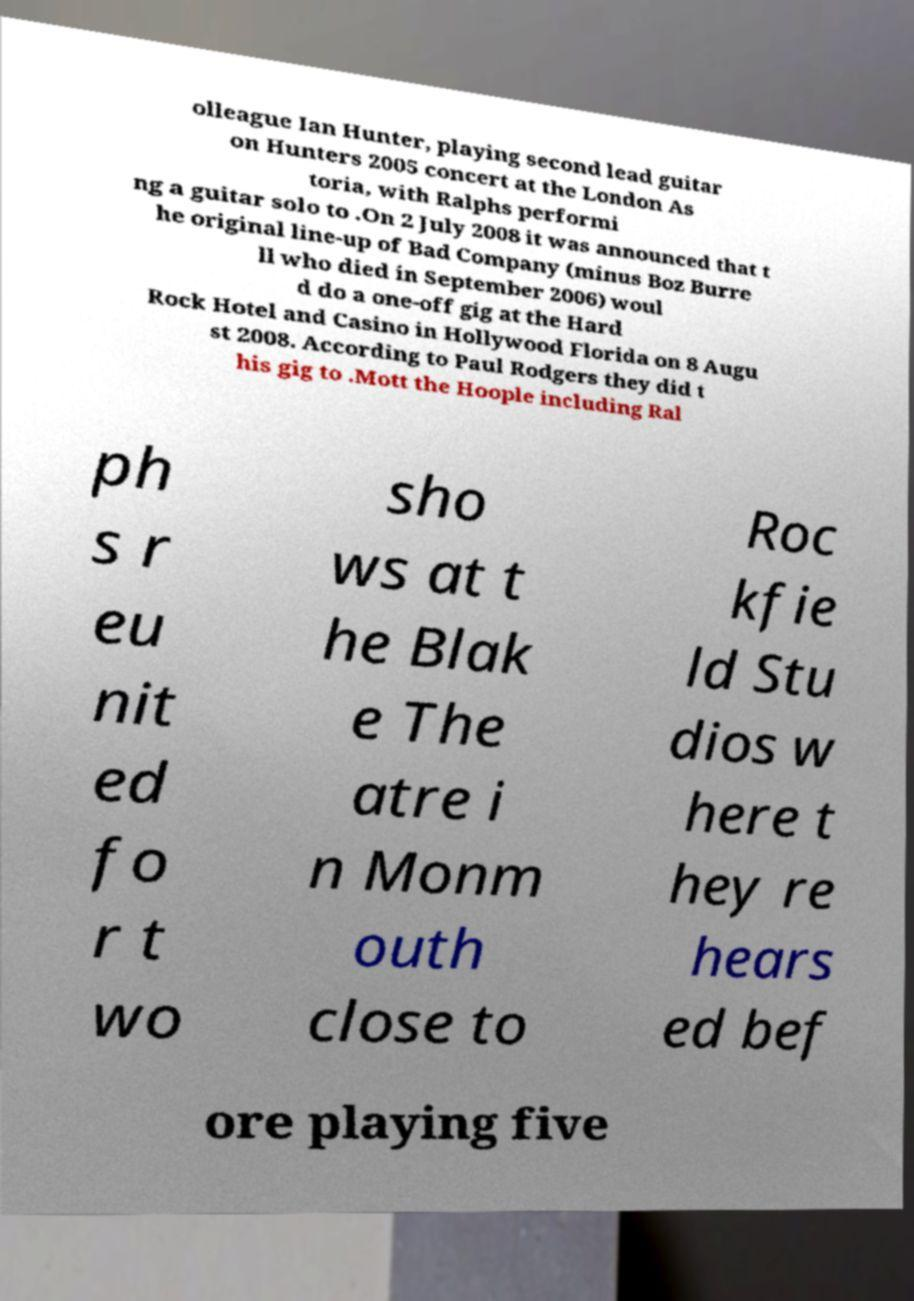Could you assist in decoding the text presented in this image and type it out clearly? olleague Ian Hunter, playing second lead guitar on Hunters 2005 concert at the London As toria, with Ralphs performi ng a guitar solo to .On 2 July 2008 it was announced that t he original line-up of Bad Company (minus Boz Burre ll who died in September 2006) woul d do a one-off gig at the Hard Rock Hotel and Casino in Hollywood Florida on 8 Augu st 2008. According to Paul Rodgers they did t his gig to .Mott the Hoople including Ral ph s r eu nit ed fo r t wo sho ws at t he Blak e The atre i n Monm outh close to Roc kfie ld Stu dios w here t hey re hears ed bef ore playing five 